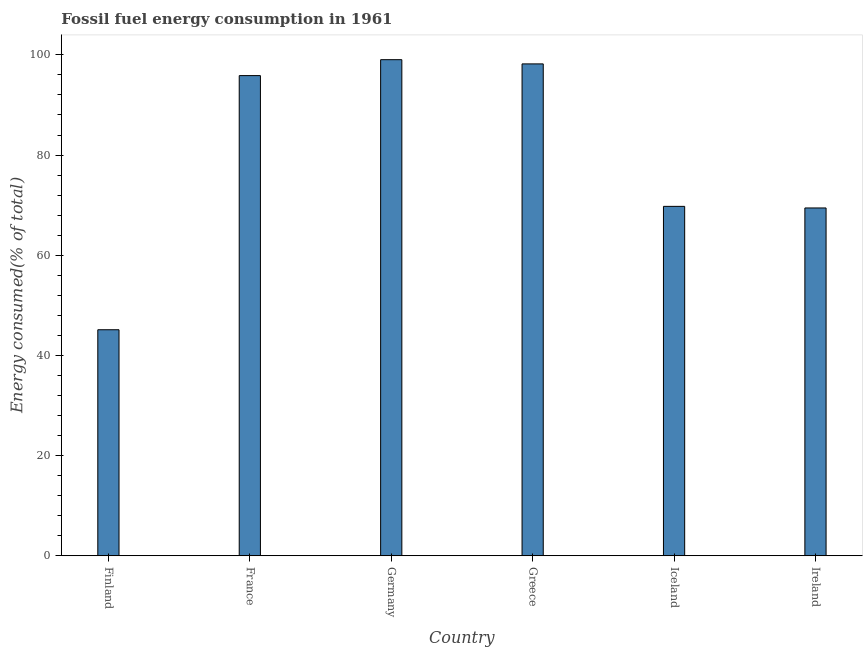What is the title of the graph?
Offer a very short reply. Fossil fuel energy consumption in 1961. What is the label or title of the X-axis?
Your answer should be very brief. Country. What is the label or title of the Y-axis?
Make the answer very short. Energy consumed(% of total). What is the fossil fuel energy consumption in Finland?
Your response must be concise. 45.13. Across all countries, what is the maximum fossil fuel energy consumption?
Offer a terse response. 99.04. Across all countries, what is the minimum fossil fuel energy consumption?
Ensure brevity in your answer.  45.13. What is the sum of the fossil fuel energy consumption?
Give a very brief answer. 477.43. What is the difference between the fossil fuel energy consumption in Greece and Iceland?
Keep it short and to the point. 28.44. What is the average fossil fuel energy consumption per country?
Your answer should be compact. 79.57. What is the median fossil fuel energy consumption?
Your response must be concise. 82.81. In how many countries, is the fossil fuel energy consumption greater than 20 %?
Your response must be concise. 6. What is the ratio of the fossil fuel energy consumption in Greece to that in Iceland?
Keep it short and to the point. 1.41. Is the difference between the fossil fuel energy consumption in Germany and Iceland greater than the difference between any two countries?
Keep it short and to the point. No. What is the difference between the highest and the second highest fossil fuel energy consumption?
Make the answer very short. 0.84. What is the difference between the highest and the lowest fossil fuel energy consumption?
Your answer should be compact. 53.91. In how many countries, is the fossil fuel energy consumption greater than the average fossil fuel energy consumption taken over all countries?
Keep it short and to the point. 3. How many countries are there in the graph?
Your response must be concise. 6. What is the Energy consumed(% of total) in Finland?
Ensure brevity in your answer.  45.13. What is the Energy consumed(% of total) in France?
Make the answer very short. 95.86. What is the Energy consumed(% of total) of Germany?
Offer a very short reply. 99.04. What is the Energy consumed(% of total) in Greece?
Your response must be concise. 98.2. What is the Energy consumed(% of total) of Iceland?
Your response must be concise. 69.76. What is the Energy consumed(% of total) of Ireland?
Provide a short and direct response. 69.44. What is the difference between the Energy consumed(% of total) in Finland and France?
Keep it short and to the point. -50.73. What is the difference between the Energy consumed(% of total) in Finland and Germany?
Offer a very short reply. -53.91. What is the difference between the Energy consumed(% of total) in Finland and Greece?
Give a very brief answer. -53.07. What is the difference between the Energy consumed(% of total) in Finland and Iceland?
Your answer should be very brief. -24.63. What is the difference between the Energy consumed(% of total) in Finland and Ireland?
Offer a very short reply. -24.31. What is the difference between the Energy consumed(% of total) in France and Germany?
Keep it short and to the point. -3.18. What is the difference between the Energy consumed(% of total) in France and Greece?
Offer a very short reply. -2.34. What is the difference between the Energy consumed(% of total) in France and Iceland?
Make the answer very short. 26.11. What is the difference between the Energy consumed(% of total) in France and Ireland?
Ensure brevity in your answer.  26.42. What is the difference between the Energy consumed(% of total) in Germany and Greece?
Provide a succinct answer. 0.84. What is the difference between the Energy consumed(% of total) in Germany and Iceland?
Your answer should be very brief. 29.28. What is the difference between the Energy consumed(% of total) in Germany and Ireland?
Keep it short and to the point. 29.6. What is the difference between the Energy consumed(% of total) in Greece and Iceland?
Provide a succinct answer. 28.44. What is the difference between the Energy consumed(% of total) in Greece and Ireland?
Provide a short and direct response. 28.76. What is the difference between the Energy consumed(% of total) in Iceland and Ireland?
Provide a short and direct response. 0.32. What is the ratio of the Energy consumed(% of total) in Finland to that in France?
Provide a short and direct response. 0.47. What is the ratio of the Energy consumed(% of total) in Finland to that in Germany?
Provide a succinct answer. 0.46. What is the ratio of the Energy consumed(% of total) in Finland to that in Greece?
Keep it short and to the point. 0.46. What is the ratio of the Energy consumed(% of total) in Finland to that in Iceland?
Make the answer very short. 0.65. What is the ratio of the Energy consumed(% of total) in Finland to that in Ireland?
Provide a succinct answer. 0.65. What is the ratio of the Energy consumed(% of total) in France to that in Germany?
Ensure brevity in your answer.  0.97. What is the ratio of the Energy consumed(% of total) in France to that in Greece?
Your response must be concise. 0.98. What is the ratio of the Energy consumed(% of total) in France to that in Iceland?
Provide a short and direct response. 1.37. What is the ratio of the Energy consumed(% of total) in France to that in Ireland?
Keep it short and to the point. 1.38. What is the ratio of the Energy consumed(% of total) in Germany to that in Greece?
Provide a succinct answer. 1.01. What is the ratio of the Energy consumed(% of total) in Germany to that in Iceland?
Your answer should be very brief. 1.42. What is the ratio of the Energy consumed(% of total) in Germany to that in Ireland?
Offer a terse response. 1.43. What is the ratio of the Energy consumed(% of total) in Greece to that in Iceland?
Give a very brief answer. 1.41. What is the ratio of the Energy consumed(% of total) in Greece to that in Ireland?
Your answer should be compact. 1.41. 